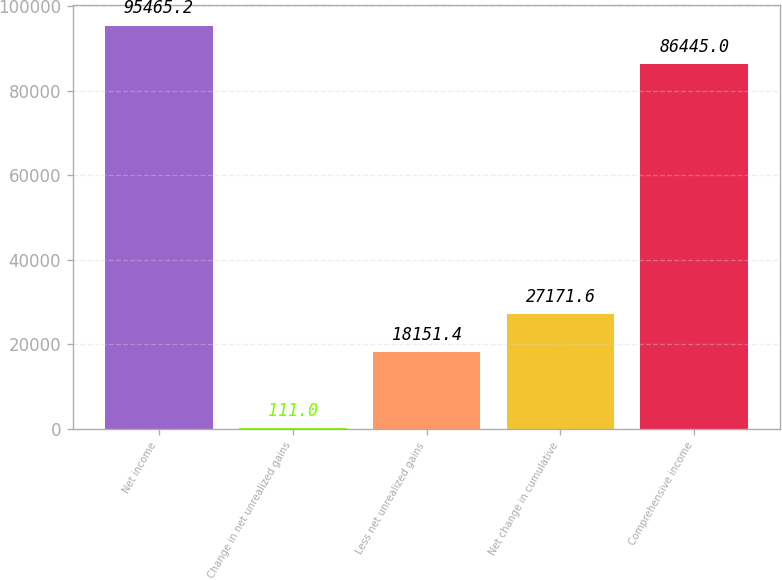Convert chart to OTSL. <chart><loc_0><loc_0><loc_500><loc_500><bar_chart><fcel>Net income<fcel>Change in net unrealized gains<fcel>Less net unrealized gains<fcel>Net change in cumulative<fcel>Comprehensive income<nl><fcel>95465.2<fcel>111<fcel>18151.4<fcel>27171.6<fcel>86445<nl></chart> 